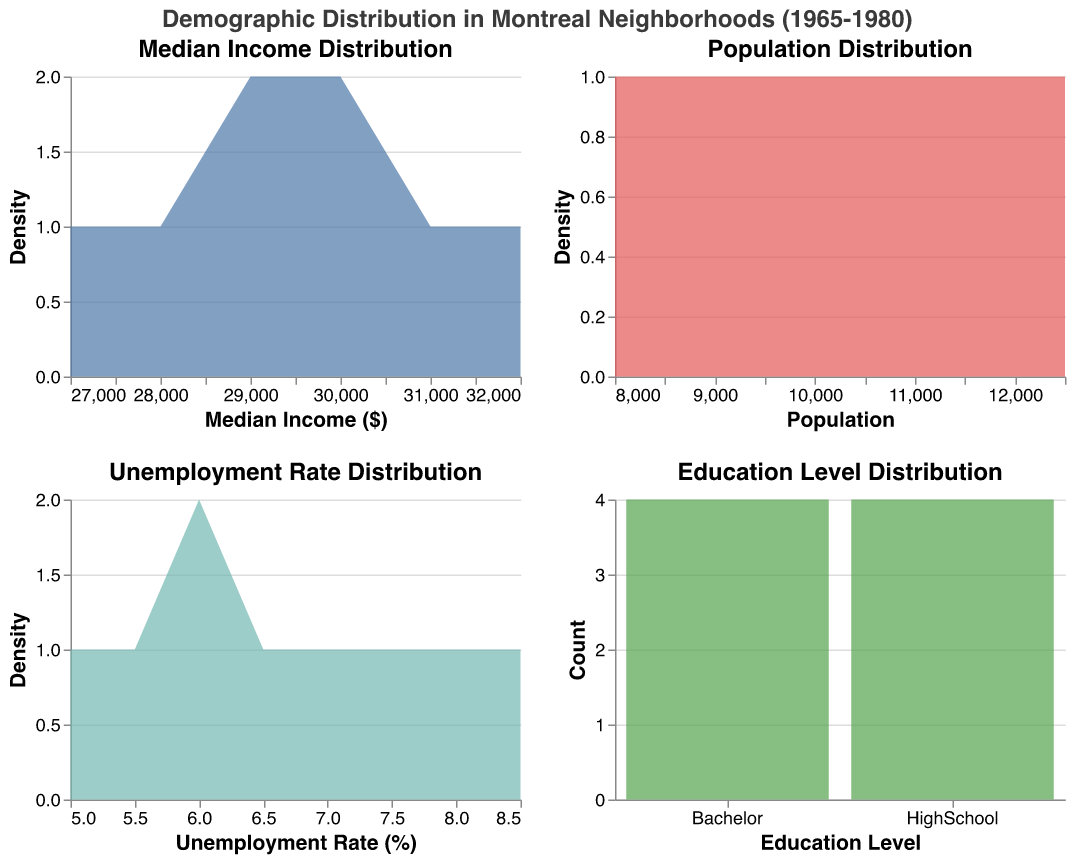What is the title of the figure? The title of the figure is clearly displayed at the top, stating the primary focus of the visualization.
Answer: Demographic Distribution in Montreal Neighborhoods (1965-1980) What neighborhood has the lowest median income in 1975? From the data, Little Burgundy in 1975 has a median income of $27,000, which is lower than Griffintown's $28,000 in the same year.
Answer: Little Burgundy Which neighborhood experienced the highest unemployment rate in 1975? By looking at the unemployment rate plot, the highest rate for 1975 can be identified. Little Burgundy had an unemployment rate of 8.5%, which is higher than Griffintown's 7.5%.
Answer: Little Burgundy Which plot shows the distribution of education levels by count? Among the four plots, the one that represents distribution using bars instead of density areas is the Education Level Distribution plot.
Answer: Education Level Distribution plot How did the population density change between Villeray in 1965 and 1970? By comparing the population points in the Population Distribution plot, in 1965 Villeray had a population of 8,000, and in 1970, it slightly increased to 8,300.
Answer: Increased slightly In which year was the median income the highest in Little Italy? The Median Income Distribution plot allows us to track changes over time. Little Italy had its highest median income in 1965, with a value of $32,000.
Answer: 1965 Which education level was more common across all neighborhoods, HighSchool or Bachelor? By counting the number of occurrences of each education level in the Education Level Distribution plot, we see that HighSchool and Bachelor are both equally common with four counts each.
Answer: Both are equally common What is the most significant observation concerning the unemployment rate in Griffintown between 1975 and 1980? By examining the Unemployment Rate Distribution plot, we can see that the unemployment rate in Griffintown decreased from 7.5% in 1975 to 5.5% in 1980, indicating a noticeable improvement.
Answer: It decreased significantly What changes occur in Little Burgundy’s median income from 1975 to 1980? By looking at the median income data for Little Burgundy, it starts at $27,000 in 1975 and increases to $29,000 in 1980.
Answer: It increased by $2,000 